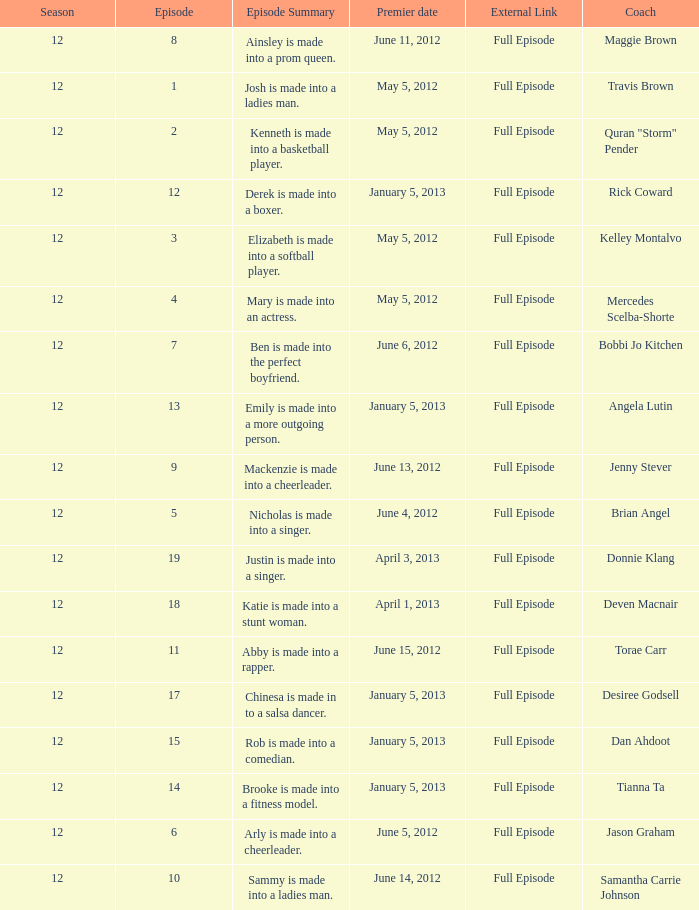Name the episode summary for travis brown Josh is made into a ladies man. 